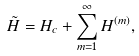<formula> <loc_0><loc_0><loc_500><loc_500>\tilde { H } = H _ { c } + \sum _ { m = 1 } ^ { \infty } H ^ { ( m ) } ,</formula> 